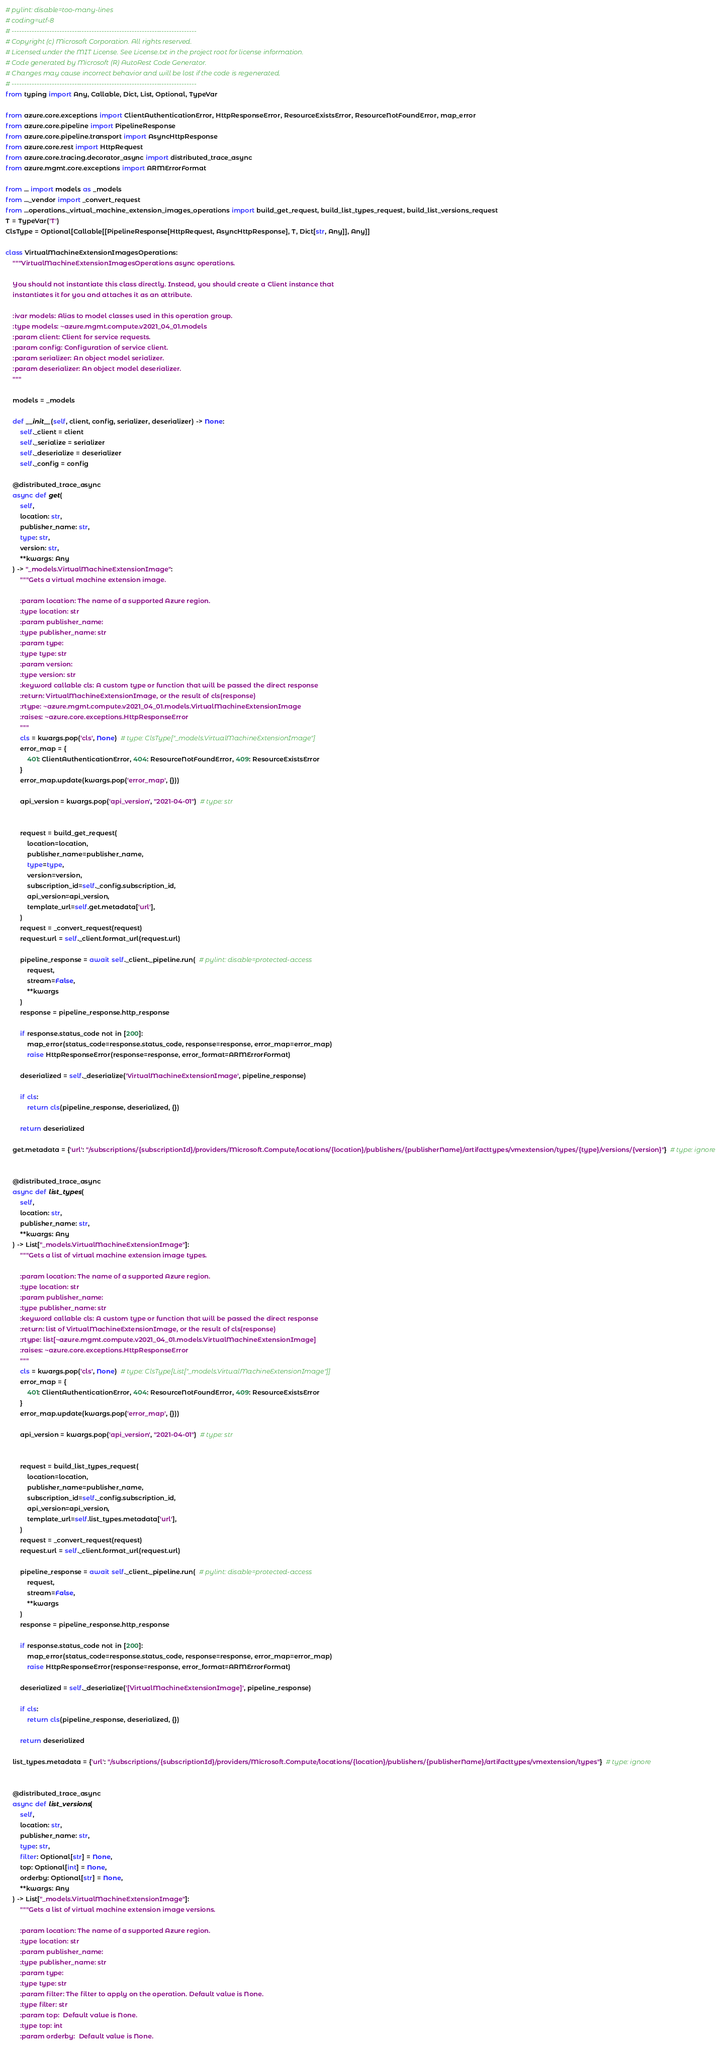Convert code to text. <code><loc_0><loc_0><loc_500><loc_500><_Python_># pylint: disable=too-many-lines
# coding=utf-8
# --------------------------------------------------------------------------
# Copyright (c) Microsoft Corporation. All rights reserved.
# Licensed under the MIT License. See License.txt in the project root for license information.
# Code generated by Microsoft (R) AutoRest Code Generator.
# Changes may cause incorrect behavior and will be lost if the code is regenerated.
# --------------------------------------------------------------------------
from typing import Any, Callable, Dict, List, Optional, TypeVar

from azure.core.exceptions import ClientAuthenticationError, HttpResponseError, ResourceExistsError, ResourceNotFoundError, map_error
from azure.core.pipeline import PipelineResponse
from azure.core.pipeline.transport import AsyncHttpResponse
from azure.core.rest import HttpRequest
from azure.core.tracing.decorator_async import distributed_trace_async
from azure.mgmt.core.exceptions import ARMErrorFormat

from ... import models as _models
from ..._vendor import _convert_request
from ...operations._virtual_machine_extension_images_operations import build_get_request, build_list_types_request, build_list_versions_request
T = TypeVar('T')
ClsType = Optional[Callable[[PipelineResponse[HttpRequest, AsyncHttpResponse], T, Dict[str, Any]], Any]]

class VirtualMachineExtensionImagesOperations:
    """VirtualMachineExtensionImagesOperations async operations.

    You should not instantiate this class directly. Instead, you should create a Client instance that
    instantiates it for you and attaches it as an attribute.

    :ivar models: Alias to model classes used in this operation group.
    :type models: ~azure.mgmt.compute.v2021_04_01.models
    :param client: Client for service requests.
    :param config: Configuration of service client.
    :param serializer: An object model serializer.
    :param deserializer: An object model deserializer.
    """

    models = _models

    def __init__(self, client, config, serializer, deserializer) -> None:
        self._client = client
        self._serialize = serializer
        self._deserialize = deserializer
        self._config = config

    @distributed_trace_async
    async def get(
        self,
        location: str,
        publisher_name: str,
        type: str,
        version: str,
        **kwargs: Any
    ) -> "_models.VirtualMachineExtensionImage":
        """Gets a virtual machine extension image.

        :param location: The name of a supported Azure region.
        :type location: str
        :param publisher_name:
        :type publisher_name: str
        :param type:
        :type type: str
        :param version:
        :type version: str
        :keyword callable cls: A custom type or function that will be passed the direct response
        :return: VirtualMachineExtensionImage, or the result of cls(response)
        :rtype: ~azure.mgmt.compute.v2021_04_01.models.VirtualMachineExtensionImage
        :raises: ~azure.core.exceptions.HttpResponseError
        """
        cls = kwargs.pop('cls', None)  # type: ClsType["_models.VirtualMachineExtensionImage"]
        error_map = {
            401: ClientAuthenticationError, 404: ResourceNotFoundError, 409: ResourceExistsError
        }
        error_map.update(kwargs.pop('error_map', {}))

        api_version = kwargs.pop('api_version', "2021-04-01")  # type: str

        
        request = build_get_request(
            location=location,
            publisher_name=publisher_name,
            type=type,
            version=version,
            subscription_id=self._config.subscription_id,
            api_version=api_version,
            template_url=self.get.metadata['url'],
        )
        request = _convert_request(request)
        request.url = self._client.format_url(request.url)

        pipeline_response = await self._client._pipeline.run(  # pylint: disable=protected-access
            request,
            stream=False,
            **kwargs
        )
        response = pipeline_response.http_response

        if response.status_code not in [200]:
            map_error(status_code=response.status_code, response=response, error_map=error_map)
            raise HttpResponseError(response=response, error_format=ARMErrorFormat)

        deserialized = self._deserialize('VirtualMachineExtensionImage', pipeline_response)

        if cls:
            return cls(pipeline_response, deserialized, {})

        return deserialized

    get.metadata = {'url': "/subscriptions/{subscriptionId}/providers/Microsoft.Compute/locations/{location}/publishers/{publisherName}/artifacttypes/vmextension/types/{type}/versions/{version}"}  # type: ignore


    @distributed_trace_async
    async def list_types(
        self,
        location: str,
        publisher_name: str,
        **kwargs: Any
    ) -> List["_models.VirtualMachineExtensionImage"]:
        """Gets a list of virtual machine extension image types.

        :param location: The name of a supported Azure region.
        :type location: str
        :param publisher_name:
        :type publisher_name: str
        :keyword callable cls: A custom type or function that will be passed the direct response
        :return: list of VirtualMachineExtensionImage, or the result of cls(response)
        :rtype: list[~azure.mgmt.compute.v2021_04_01.models.VirtualMachineExtensionImage]
        :raises: ~azure.core.exceptions.HttpResponseError
        """
        cls = kwargs.pop('cls', None)  # type: ClsType[List["_models.VirtualMachineExtensionImage"]]
        error_map = {
            401: ClientAuthenticationError, 404: ResourceNotFoundError, 409: ResourceExistsError
        }
        error_map.update(kwargs.pop('error_map', {}))

        api_version = kwargs.pop('api_version', "2021-04-01")  # type: str

        
        request = build_list_types_request(
            location=location,
            publisher_name=publisher_name,
            subscription_id=self._config.subscription_id,
            api_version=api_version,
            template_url=self.list_types.metadata['url'],
        )
        request = _convert_request(request)
        request.url = self._client.format_url(request.url)

        pipeline_response = await self._client._pipeline.run(  # pylint: disable=protected-access
            request,
            stream=False,
            **kwargs
        )
        response = pipeline_response.http_response

        if response.status_code not in [200]:
            map_error(status_code=response.status_code, response=response, error_map=error_map)
            raise HttpResponseError(response=response, error_format=ARMErrorFormat)

        deserialized = self._deserialize('[VirtualMachineExtensionImage]', pipeline_response)

        if cls:
            return cls(pipeline_response, deserialized, {})

        return deserialized

    list_types.metadata = {'url': "/subscriptions/{subscriptionId}/providers/Microsoft.Compute/locations/{location}/publishers/{publisherName}/artifacttypes/vmextension/types"}  # type: ignore


    @distributed_trace_async
    async def list_versions(
        self,
        location: str,
        publisher_name: str,
        type: str,
        filter: Optional[str] = None,
        top: Optional[int] = None,
        orderby: Optional[str] = None,
        **kwargs: Any
    ) -> List["_models.VirtualMachineExtensionImage"]:
        """Gets a list of virtual machine extension image versions.

        :param location: The name of a supported Azure region.
        :type location: str
        :param publisher_name:
        :type publisher_name: str
        :param type:
        :type type: str
        :param filter: The filter to apply on the operation. Default value is None.
        :type filter: str
        :param top:  Default value is None.
        :type top: int
        :param orderby:  Default value is None.</code> 